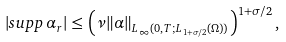<formula> <loc_0><loc_0><loc_500><loc_500>| s u p p \, \alpha _ { r } | \leq \left ( \nu \| \alpha \| _ { L _ { \infty } ( 0 , T ; L _ { 1 + \sigma / 2 } ( \Omega ) ) } \right ) ^ { 1 + \sigma / 2 } ,</formula> 